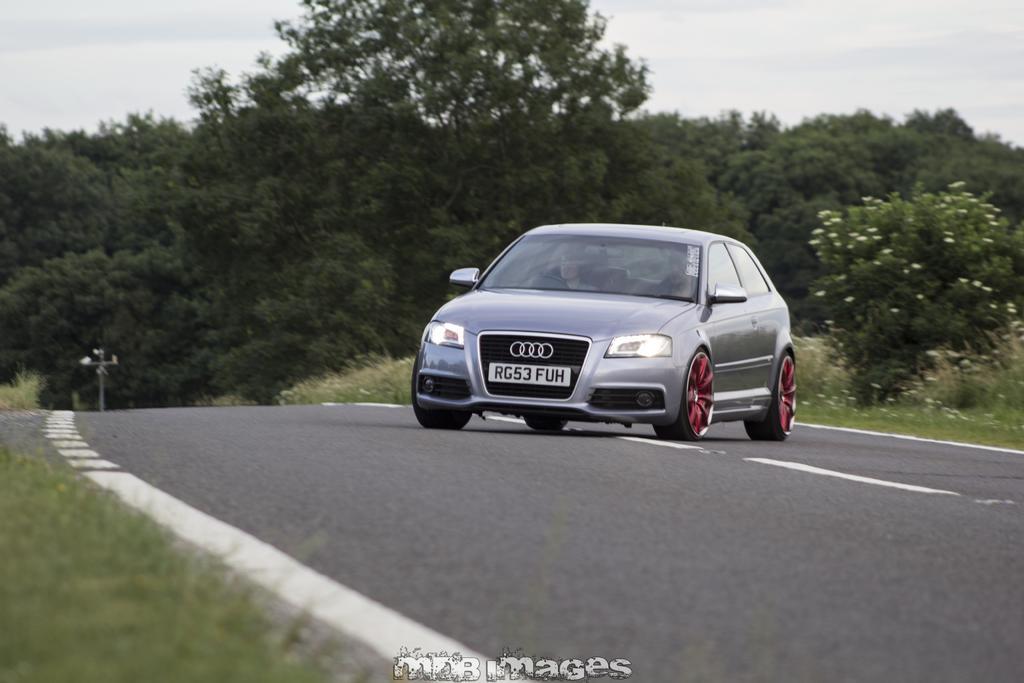Describe this image in one or two sentences. In this picture there is a car on the road and there are trees in the background. 